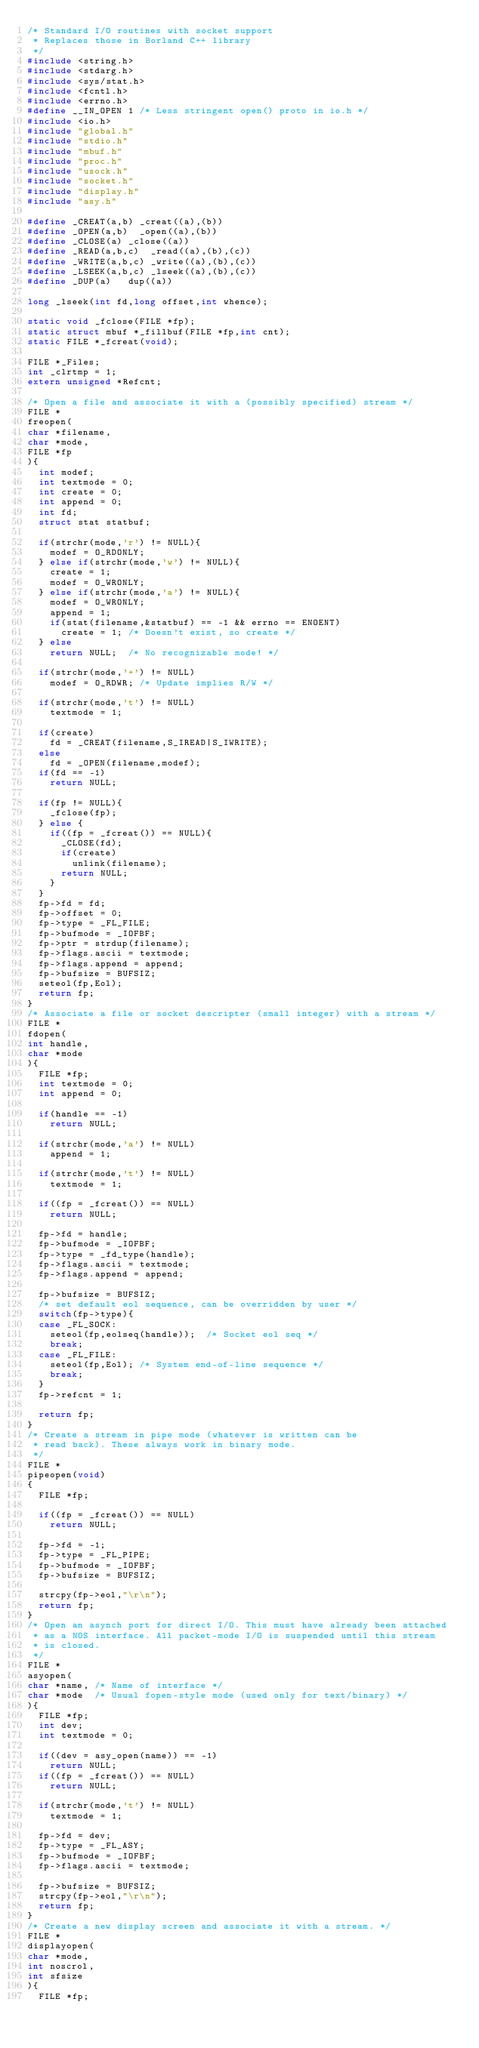Convert code to text. <code><loc_0><loc_0><loc_500><loc_500><_C_>/* Standard I/O routines with socket support
 * Replaces those in Borland C++ library
 */
#include <string.h>
#include <stdarg.h>
#include <sys/stat.h>
#include <fcntl.h>
#include <errno.h>
#define __IN_OPEN	1	/* Less stringent open() proto in io.h */
#include <io.h>
#include "global.h"
#include "stdio.h"
#include "mbuf.h"
#include "proc.h"
#include "usock.h"
#include "socket.h"
#include "display.h"
#include "asy.h"

#define	_CREAT(a,b)	_creat((a),(b))
#define _OPEN(a,b)	_open((a),(b))
#define	_CLOSE(a)	_close((a))
#define	_READ(a,b,c)	_read((a),(b),(c))
#define	_WRITE(a,b,c)	_write((a),(b),(c))
#define	_LSEEK(a,b,c)	_lseek((a),(b),(c))
#define	_DUP(a)		dup((a))

long _lseek(int fd,long offset,int whence);

static void _fclose(FILE *fp);
static struct mbuf *_fillbuf(FILE *fp,int cnt);
static FILE *_fcreat(void);

FILE *_Files;
int _clrtmp = 1;
extern unsigned *Refcnt;

/* Open a file and associate it with a (possibly specified) stream */
FILE *
freopen(
char *filename,
char *mode,
FILE *fp
){
	int modef;
	int textmode = 0;
	int create = 0;
	int append = 0;
	int fd;
	struct stat statbuf;

	if(strchr(mode,'r') != NULL){
		modef = O_RDONLY;
	} else if(strchr(mode,'w') != NULL){
		create = 1;
		modef = O_WRONLY;
	} else if(strchr(mode,'a') != NULL){
		modef = O_WRONLY;
		append = 1;
		if(stat(filename,&statbuf) == -1 && errno == ENOENT)
			create = 1;	/* Doesn't exist, so create */
	} else
		return NULL;	/* No recognizable mode! */

	if(strchr(mode,'+') != NULL)
		modef = O_RDWR;	/* Update implies R/W */

	if(strchr(mode,'t') != NULL)
		textmode = 1;
	
	if(create)
		fd = _CREAT(filename,S_IREAD|S_IWRITE);
	else
		fd = _OPEN(filename,modef);
	if(fd == -1)
		return NULL;

	if(fp != NULL){
		_fclose(fp);
	} else {
		if((fp = _fcreat()) == NULL){
			_CLOSE(fd);
			if(create)
				unlink(filename);
			return NULL;
		}
	}
	fp->fd = fd;
	fp->offset = 0;
	fp->type = _FL_FILE;
	fp->bufmode = _IOFBF;
	fp->ptr = strdup(filename);
	fp->flags.ascii = textmode;
	fp->flags.append = append;
	fp->bufsize = BUFSIZ;
	seteol(fp,Eol);
	return fp;
}
/* Associate a file or socket descripter (small integer) with a stream */
FILE *
fdopen(
int handle,
char *mode
){
	FILE *fp;
	int textmode = 0;
	int append = 0;

	if(handle == -1)
		return NULL;

	if(strchr(mode,'a') != NULL)
		append = 1;

	if(strchr(mode,'t') != NULL)
		textmode = 1;
	
	if((fp = _fcreat()) == NULL)
		return NULL;

	fp->fd = handle;
	fp->bufmode = _IOFBF;
	fp->type = _fd_type(handle);
	fp->flags.ascii = textmode;
	fp->flags.append = append;

	fp->bufsize = BUFSIZ;
	/* set default eol sequence, can be overridden by user */
	switch(fp->type){
	case _FL_SOCK:
		seteol(fp,eolseq(handle));	/* Socket eol seq */
		break;
	case _FL_FILE:
		seteol(fp,Eol);	/* System end-of-line sequence */
		break;
	}
	fp->refcnt = 1;

	return fp;
}
/* Create a stream in pipe mode (whatever is written can be
 * read back). These always work in binary mode.
 */
FILE *
pipeopen(void)
{
	FILE *fp;

	if((fp = _fcreat()) == NULL)
		return NULL;

	fp->fd = -1;
	fp->type = _FL_PIPE;
	fp->bufmode = _IOFBF;
	fp->bufsize = BUFSIZ;

	strcpy(fp->eol,"\r\n");
	return fp;
}
/* Open an asynch port for direct I/O. This must have already been attached
 * as a NOS interface. All packet-mode I/O is suspended until this stream
 * is closed.
 */
FILE *
asyopen(
char *name,	/* Name of interface */
char *mode	/* Usual fopen-style mode (used only for text/binary) */
){
	FILE *fp;
	int dev;
	int textmode = 0;

	if((dev = asy_open(name)) == -1)
		return NULL;
	if((fp = _fcreat()) == NULL)
		return NULL;

	if(strchr(mode,'t') != NULL)
		textmode = 1;

	fp->fd = dev;
	fp->type = _FL_ASY;
	fp->bufmode = _IOFBF;
	fp->flags.ascii = textmode;

	fp->bufsize = BUFSIZ;
	strcpy(fp->eol,"\r\n");
	return fp;
}
/* Create a new display screen and associate it with a stream. */
FILE *
displayopen(
char *mode,
int noscrol,
int sfsize
){
	FILE *fp;</code> 